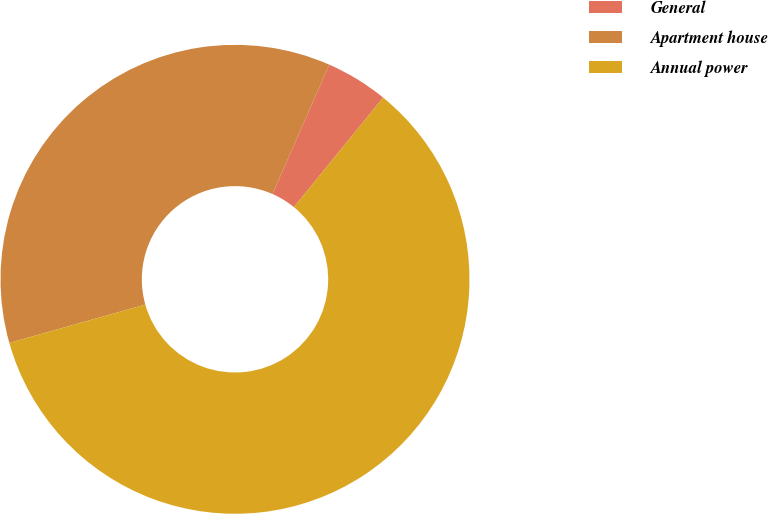<chart> <loc_0><loc_0><loc_500><loc_500><pie_chart><fcel>General<fcel>Apartment house<fcel>Annual power<nl><fcel>4.3%<fcel>35.96%<fcel>59.74%<nl></chart> 